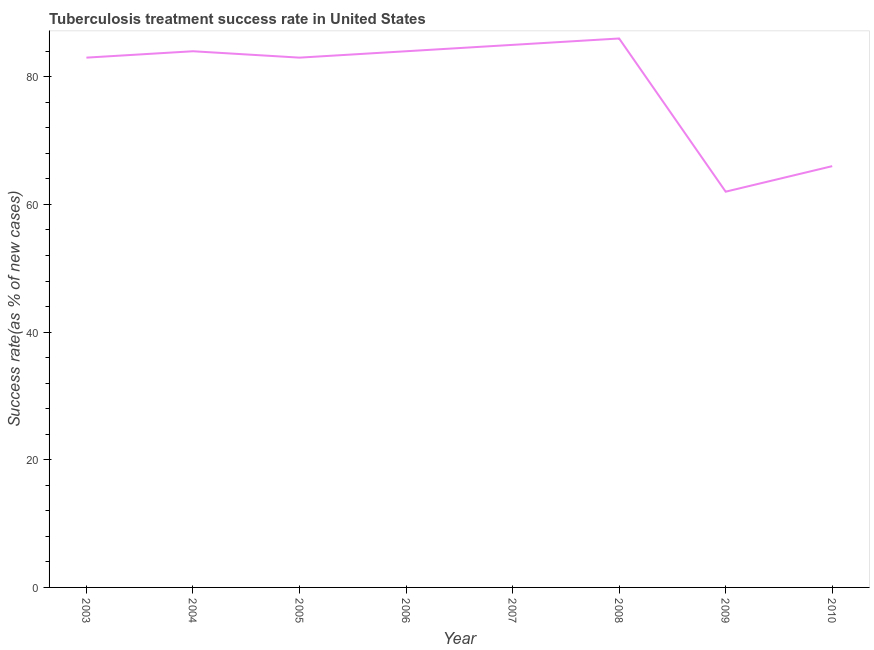What is the tuberculosis treatment success rate in 2009?
Your response must be concise. 62. Across all years, what is the maximum tuberculosis treatment success rate?
Offer a terse response. 86. Across all years, what is the minimum tuberculosis treatment success rate?
Offer a very short reply. 62. In which year was the tuberculosis treatment success rate maximum?
Give a very brief answer. 2008. What is the sum of the tuberculosis treatment success rate?
Your response must be concise. 633. What is the difference between the tuberculosis treatment success rate in 2005 and 2009?
Offer a very short reply. 21. What is the average tuberculosis treatment success rate per year?
Provide a short and direct response. 79.12. What is the median tuberculosis treatment success rate?
Give a very brief answer. 83.5. Do a majority of the years between 2009 and 2006 (inclusive) have tuberculosis treatment success rate greater than 80 %?
Offer a very short reply. Yes. What is the ratio of the tuberculosis treatment success rate in 2006 to that in 2010?
Your answer should be very brief. 1.27. Is the tuberculosis treatment success rate in 2004 less than that in 2008?
Your answer should be very brief. Yes. Is the sum of the tuberculosis treatment success rate in 2004 and 2008 greater than the maximum tuberculosis treatment success rate across all years?
Your answer should be compact. Yes. What is the difference between the highest and the lowest tuberculosis treatment success rate?
Your response must be concise. 24. In how many years, is the tuberculosis treatment success rate greater than the average tuberculosis treatment success rate taken over all years?
Give a very brief answer. 6. How many lines are there?
Ensure brevity in your answer.  1. What is the difference between two consecutive major ticks on the Y-axis?
Ensure brevity in your answer.  20. Does the graph contain any zero values?
Provide a succinct answer. No. What is the title of the graph?
Offer a terse response. Tuberculosis treatment success rate in United States. What is the label or title of the X-axis?
Your response must be concise. Year. What is the label or title of the Y-axis?
Your response must be concise. Success rate(as % of new cases). What is the Success rate(as % of new cases) in 2005?
Your answer should be compact. 83. What is the Success rate(as % of new cases) of 2007?
Make the answer very short. 85. What is the Success rate(as % of new cases) of 2009?
Your answer should be compact. 62. What is the difference between the Success rate(as % of new cases) in 2003 and 2007?
Offer a terse response. -2. What is the difference between the Success rate(as % of new cases) in 2003 and 2009?
Ensure brevity in your answer.  21. What is the difference between the Success rate(as % of new cases) in 2003 and 2010?
Provide a succinct answer. 17. What is the difference between the Success rate(as % of new cases) in 2004 and 2005?
Provide a short and direct response. 1. What is the difference between the Success rate(as % of new cases) in 2004 and 2008?
Provide a short and direct response. -2. What is the difference between the Success rate(as % of new cases) in 2005 and 2006?
Make the answer very short. -1. What is the difference between the Success rate(as % of new cases) in 2005 and 2009?
Offer a terse response. 21. What is the difference between the Success rate(as % of new cases) in 2005 and 2010?
Provide a short and direct response. 17. What is the difference between the Success rate(as % of new cases) in 2006 and 2008?
Keep it short and to the point. -2. What is the difference between the Success rate(as % of new cases) in 2007 and 2008?
Offer a very short reply. -1. What is the ratio of the Success rate(as % of new cases) in 2003 to that in 2004?
Offer a terse response. 0.99. What is the ratio of the Success rate(as % of new cases) in 2003 to that in 2008?
Your answer should be compact. 0.96. What is the ratio of the Success rate(as % of new cases) in 2003 to that in 2009?
Provide a succinct answer. 1.34. What is the ratio of the Success rate(as % of new cases) in 2003 to that in 2010?
Offer a very short reply. 1.26. What is the ratio of the Success rate(as % of new cases) in 2004 to that in 2006?
Make the answer very short. 1. What is the ratio of the Success rate(as % of new cases) in 2004 to that in 2009?
Make the answer very short. 1.35. What is the ratio of the Success rate(as % of new cases) in 2004 to that in 2010?
Offer a terse response. 1.27. What is the ratio of the Success rate(as % of new cases) in 2005 to that in 2006?
Provide a succinct answer. 0.99. What is the ratio of the Success rate(as % of new cases) in 2005 to that in 2007?
Provide a succinct answer. 0.98. What is the ratio of the Success rate(as % of new cases) in 2005 to that in 2009?
Give a very brief answer. 1.34. What is the ratio of the Success rate(as % of new cases) in 2005 to that in 2010?
Ensure brevity in your answer.  1.26. What is the ratio of the Success rate(as % of new cases) in 2006 to that in 2008?
Your answer should be compact. 0.98. What is the ratio of the Success rate(as % of new cases) in 2006 to that in 2009?
Keep it short and to the point. 1.35. What is the ratio of the Success rate(as % of new cases) in 2006 to that in 2010?
Your answer should be compact. 1.27. What is the ratio of the Success rate(as % of new cases) in 2007 to that in 2009?
Keep it short and to the point. 1.37. What is the ratio of the Success rate(as % of new cases) in 2007 to that in 2010?
Provide a short and direct response. 1.29. What is the ratio of the Success rate(as % of new cases) in 2008 to that in 2009?
Offer a very short reply. 1.39. What is the ratio of the Success rate(as % of new cases) in 2008 to that in 2010?
Offer a terse response. 1.3. What is the ratio of the Success rate(as % of new cases) in 2009 to that in 2010?
Provide a short and direct response. 0.94. 